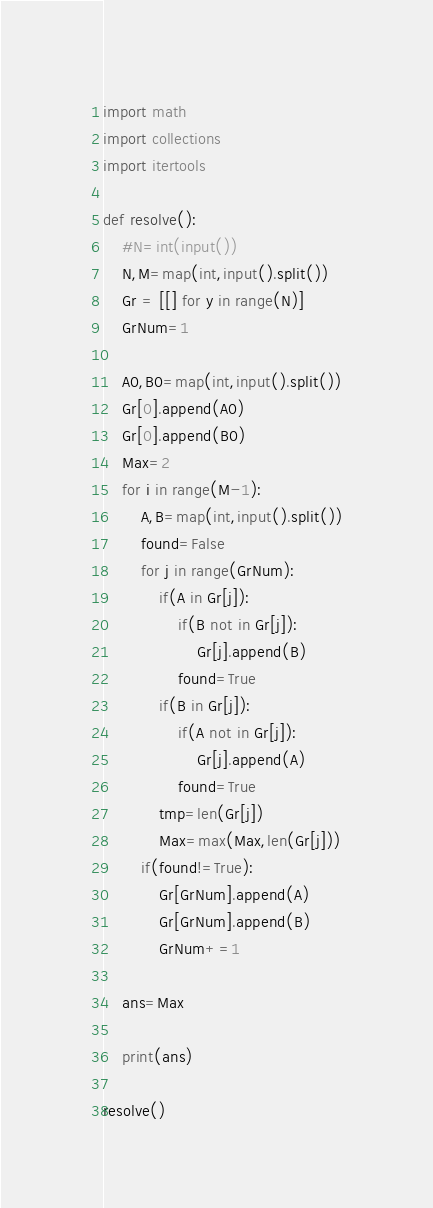Convert code to text. <code><loc_0><loc_0><loc_500><loc_500><_Python_>import math
import collections
import itertools

def resolve():
    #N=int(input())
    N,M=map(int,input().split())
    Gr = [[] for y in range(N)]
    GrNum=1

    A0,B0=map(int,input().split())
    Gr[0].append(A0)
    Gr[0].append(B0)
    Max=2
    for i in range(M-1):
        A,B=map(int,input().split())
        found=False
        for j in range(GrNum):
            if(A in Gr[j]):
                if(B not in Gr[j]):
                    Gr[j].append(B)
                found=True
            if(B in Gr[j]):
                if(A not in Gr[j]):
                    Gr[j].append(A)
                found=True
            tmp=len(Gr[j])
            Max=max(Max,len(Gr[j]))
        if(found!=True):
            Gr[GrNum].append(A)
            Gr[GrNum].append(B)
            GrNum+=1                

    ans=Max

    print(ans)

resolve()</code> 